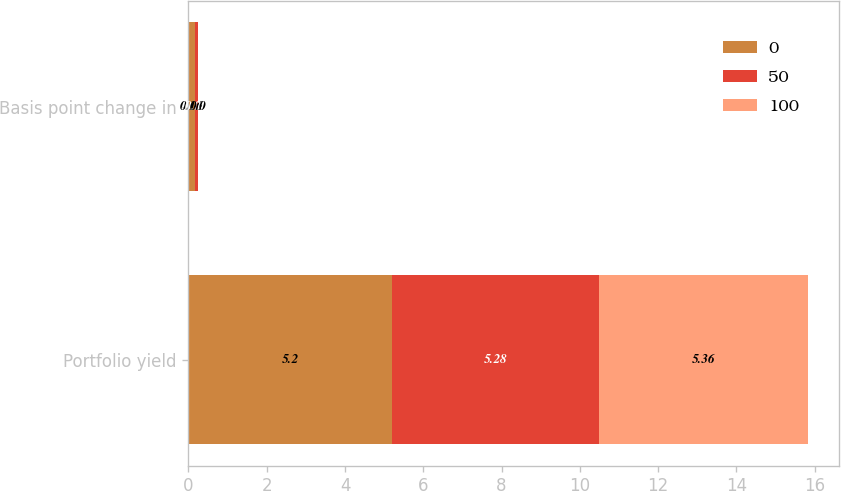Convert chart. <chart><loc_0><loc_0><loc_500><loc_500><stacked_bar_chart><ecel><fcel>Portfolio yield<fcel>Basis point change in<nl><fcel>0<fcel>5.2<fcel>0.16<nl><fcel>50<fcel>5.28<fcel>0.08<nl><fcel>100<fcel>5.36<fcel>0<nl></chart> 